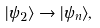Convert formula to latex. <formula><loc_0><loc_0><loc_500><loc_500>| \psi _ { 2 } \rangle \rightarrow | \psi _ { n } \rangle ,</formula> 